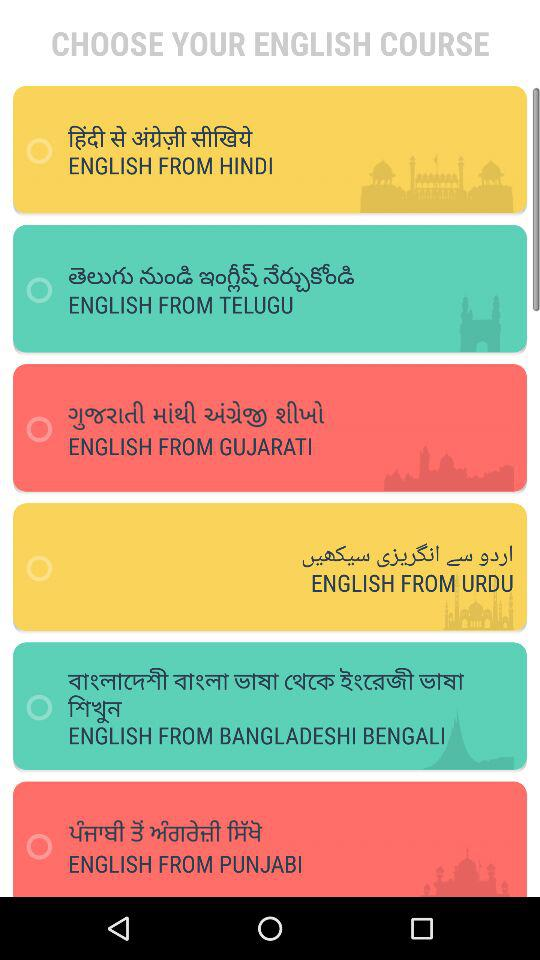How many courses are available to learn English?
Answer the question using a single word or phrase. 6 